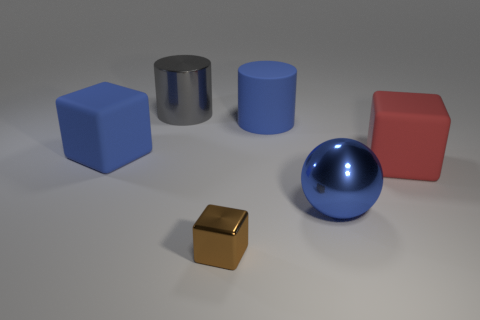Subtract all blue cubes. How many cubes are left? 2 Subtract all blue blocks. How many blocks are left? 2 Subtract 2 blocks. How many blocks are left? 1 Add 4 balls. How many objects exist? 10 Subtract all spheres. How many objects are left? 5 Subtract all brown cubes. Subtract all purple spheres. How many cubes are left? 2 Subtract all blue things. Subtract all small brown rubber cylinders. How many objects are left? 3 Add 2 rubber cylinders. How many rubber cylinders are left? 3 Add 2 blue matte things. How many blue matte things exist? 4 Subtract 0 purple spheres. How many objects are left? 6 